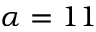Convert formula to latex. <formula><loc_0><loc_0><loc_500><loc_500>\alpha = 1 1</formula> 